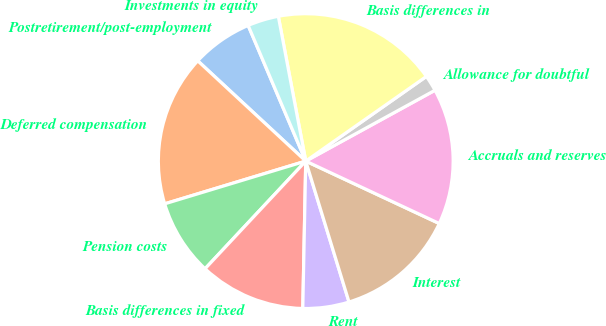Convert chart. <chart><loc_0><loc_0><loc_500><loc_500><pie_chart><fcel>Postretirement/post-employment<fcel>Deferred compensation<fcel>Pension costs<fcel>Basis differences in fixed<fcel>Rent<fcel>Interest<fcel>Accruals and reserves<fcel>Allowance for doubtful<fcel>Basis differences in<fcel>Investments in equity<nl><fcel>6.7%<fcel>16.59%<fcel>8.35%<fcel>11.65%<fcel>5.06%<fcel>13.3%<fcel>14.94%<fcel>1.76%<fcel>18.24%<fcel>3.41%<nl></chart> 